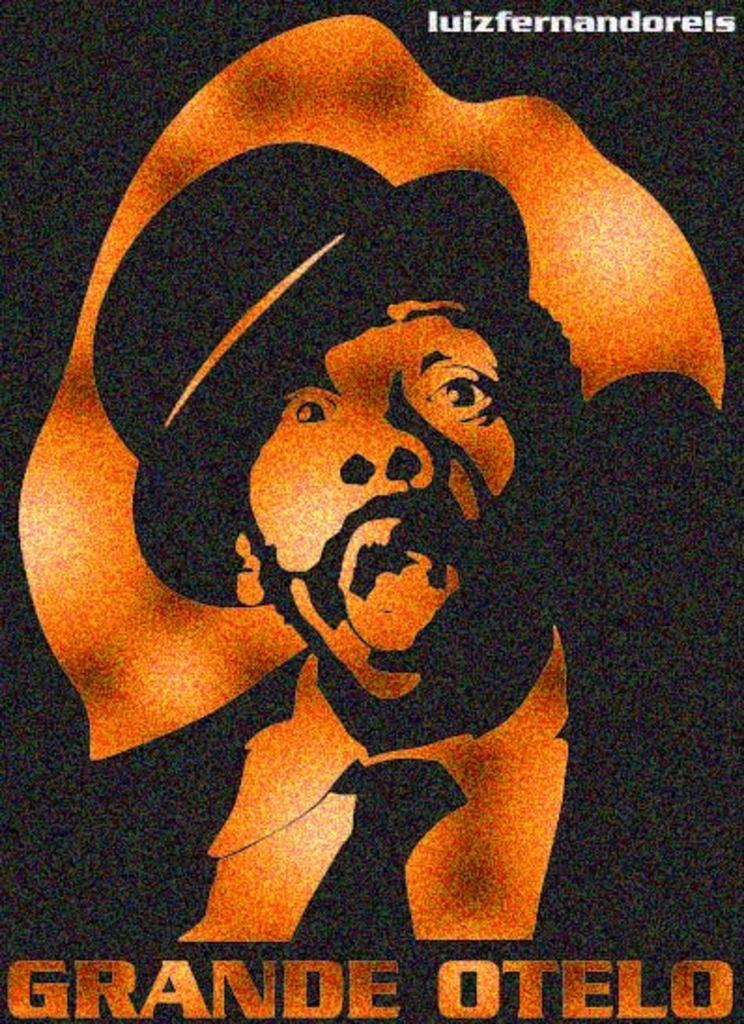<image>
Give a short and clear explanation of the subsequent image. Cover that shows a man's face looking shocked and the name Grande Otelo there. 